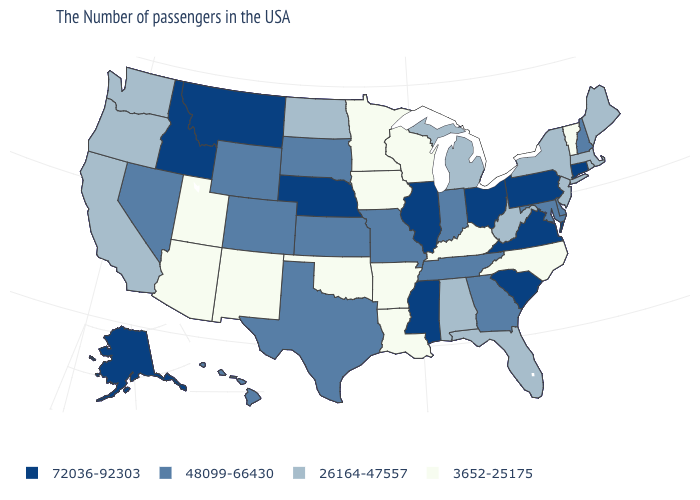Does Iowa have the lowest value in the MidWest?
Concise answer only. Yes. Among the states that border Oregon , which have the lowest value?
Write a very short answer. California, Washington. Is the legend a continuous bar?
Give a very brief answer. No. What is the value of New Mexico?
Keep it brief. 3652-25175. What is the value of West Virginia?
Write a very short answer. 26164-47557. What is the value of Rhode Island?
Be succinct. 26164-47557. Does California have a lower value than Missouri?
Keep it brief. Yes. Does Minnesota have the highest value in the USA?
Short answer required. No. Name the states that have a value in the range 72036-92303?
Concise answer only. Connecticut, Pennsylvania, Virginia, South Carolina, Ohio, Illinois, Mississippi, Nebraska, Montana, Idaho, Alaska. What is the value of Illinois?
Keep it brief. 72036-92303. Does the map have missing data?
Keep it brief. No. What is the value of Virginia?
Keep it brief. 72036-92303. Name the states that have a value in the range 72036-92303?
Write a very short answer. Connecticut, Pennsylvania, Virginia, South Carolina, Ohio, Illinois, Mississippi, Nebraska, Montana, Idaho, Alaska. Which states hav the highest value in the MidWest?
Short answer required. Ohio, Illinois, Nebraska. Among the states that border Iowa , which have the highest value?
Write a very short answer. Illinois, Nebraska. 